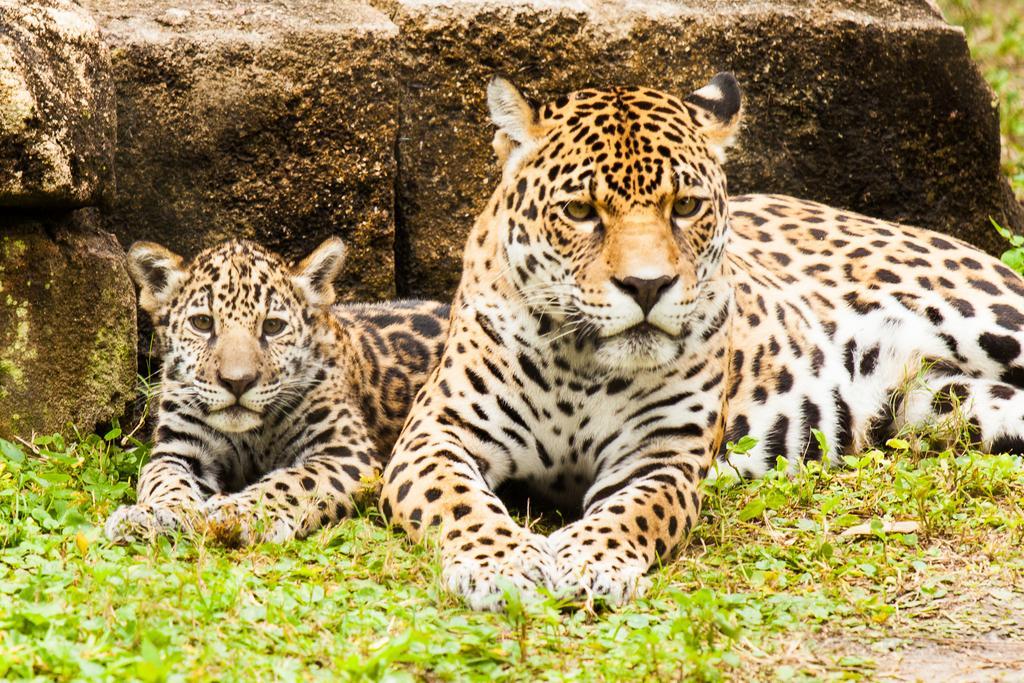Could you give a brief overview of what you see in this image? In this picture we can see animals on the ground, here we can see the grass and in the background we can see rocks. 